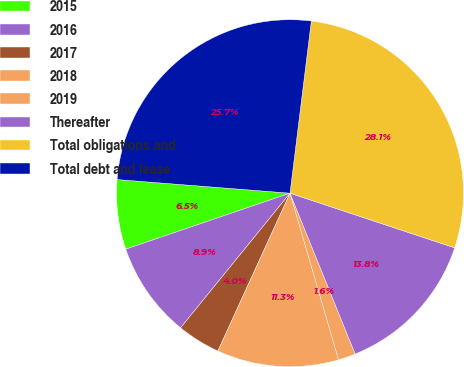Convert chart to OTSL. <chart><loc_0><loc_0><loc_500><loc_500><pie_chart><fcel>2015<fcel>2016<fcel>2017<fcel>2018<fcel>2019<fcel>Thereafter<fcel>Total obligations and<fcel>Total debt and lease<nl><fcel>6.48%<fcel>8.91%<fcel>4.04%<fcel>11.34%<fcel>1.61%<fcel>13.78%<fcel>28.14%<fcel>25.71%<nl></chart> 